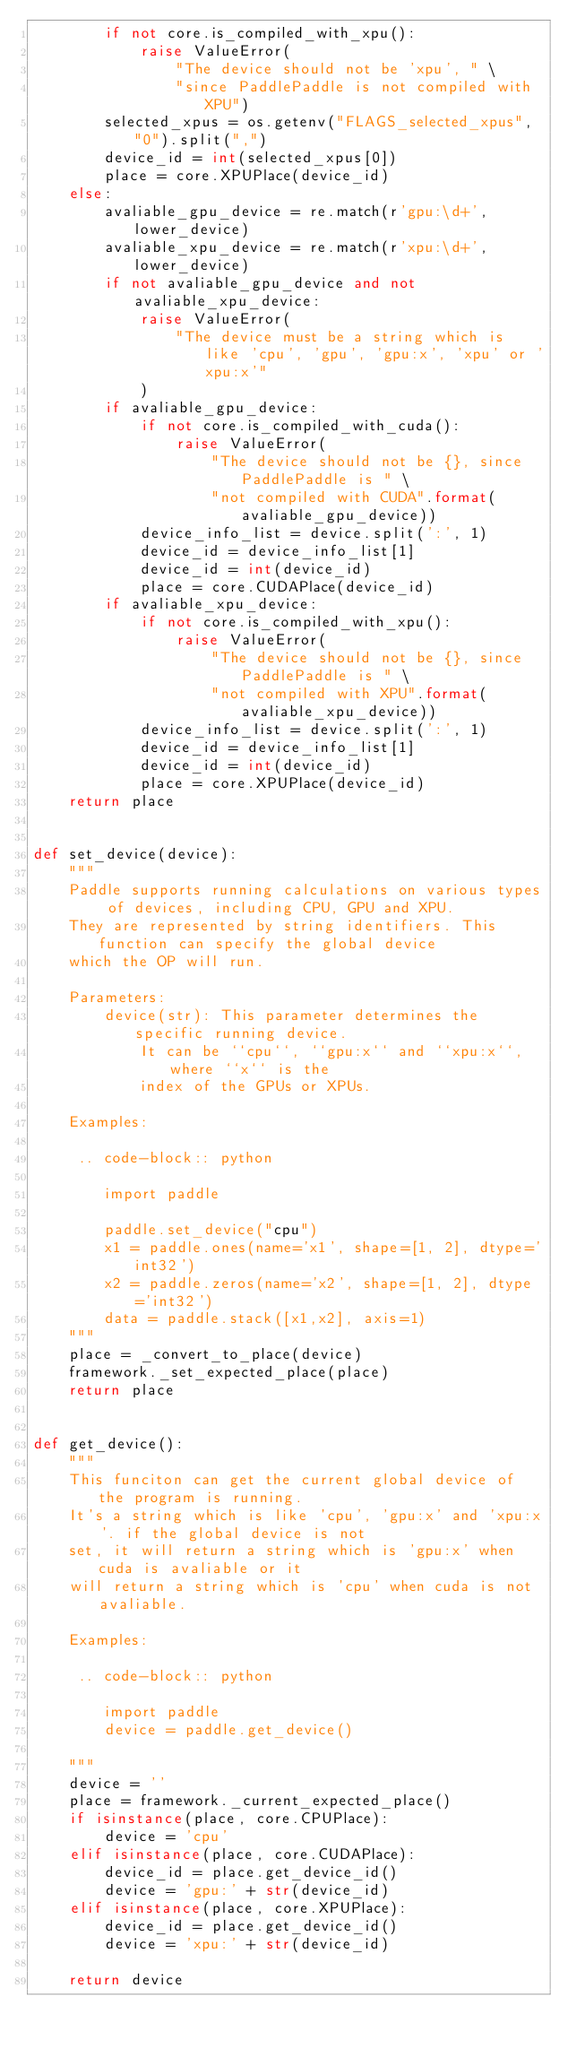<code> <loc_0><loc_0><loc_500><loc_500><_Python_>        if not core.is_compiled_with_xpu():
            raise ValueError(
                "The device should not be 'xpu', " \
                "since PaddlePaddle is not compiled with XPU")
        selected_xpus = os.getenv("FLAGS_selected_xpus", "0").split(",")
        device_id = int(selected_xpus[0])
        place = core.XPUPlace(device_id)
    else:
        avaliable_gpu_device = re.match(r'gpu:\d+', lower_device)
        avaliable_xpu_device = re.match(r'xpu:\d+', lower_device)
        if not avaliable_gpu_device and not avaliable_xpu_device:
            raise ValueError(
                "The device must be a string which is like 'cpu', 'gpu', 'gpu:x', 'xpu' or 'xpu:x'"
            )
        if avaliable_gpu_device:
            if not core.is_compiled_with_cuda():
                raise ValueError(
                    "The device should not be {}, since PaddlePaddle is " \
                    "not compiled with CUDA".format(avaliable_gpu_device))
            device_info_list = device.split(':', 1)
            device_id = device_info_list[1]
            device_id = int(device_id)
            place = core.CUDAPlace(device_id)
        if avaliable_xpu_device:
            if not core.is_compiled_with_xpu():
                raise ValueError(
                    "The device should not be {}, since PaddlePaddle is " \
                    "not compiled with XPU".format(avaliable_xpu_device))
            device_info_list = device.split(':', 1)
            device_id = device_info_list[1]
            device_id = int(device_id)
            place = core.XPUPlace(device_id)
    return place


def set_device(device):
    """
    Paddle supports running calculations on various types of devices, including CPU, GPU and XPU.
    They are represented by string identifiers. This function can specify the global device
    which the OP will run.

    Parameters:
        device(str): This parameter determines the specific running device.
            It can be ``cpu``, ``gpu:x`` and ``xpu:x``, where ``x`` is the 
            index of the GPUs or XPUs. 

    Examples:

     .. code-block:: python
            
        import paddle

        paddle.set_device("cpu")
        x1 = paddle.ones(name='x1', shape=[1, 2], dtype='int32')
        x2 = paddle.zeros(name='x2', shape=[1, 2], dtype='int32')
        data = paddle.stack([x1,x2], axis=1)
    """
    place = _convert_to_place(device)
    framework._set_expected_place(place)
    return place


def get_device():
    """
    This funciton can get the current global device of the program is running.
    It's a string which is like 'cpu', 'gpu:x' and 'xpu:x'. if the global device is not
    set, it will return a string which is 'gpu:x' when cuda is avaliable or it 
    will return a string which is 'cpu' when cuda is not avaliable.

    Examples:

     .. code-block:: python
            
        import paddle
        device = paddle.get_device()

    """
    device = ''
    place = framework._current_expected_place()
    if isinstance(place, core.CPUPlace):
        device = 'cpu'
    elif isinstance(place, core.CUDAPlace):
        device_id = place.get_device_id()
        device = 'gpu:' + str(device_id)
    elif isinstance(place, core.XPUPlace):
        device_id = place.get_device_id()
        device = 'xpu:' + str(device_id)

    return device
</code> 